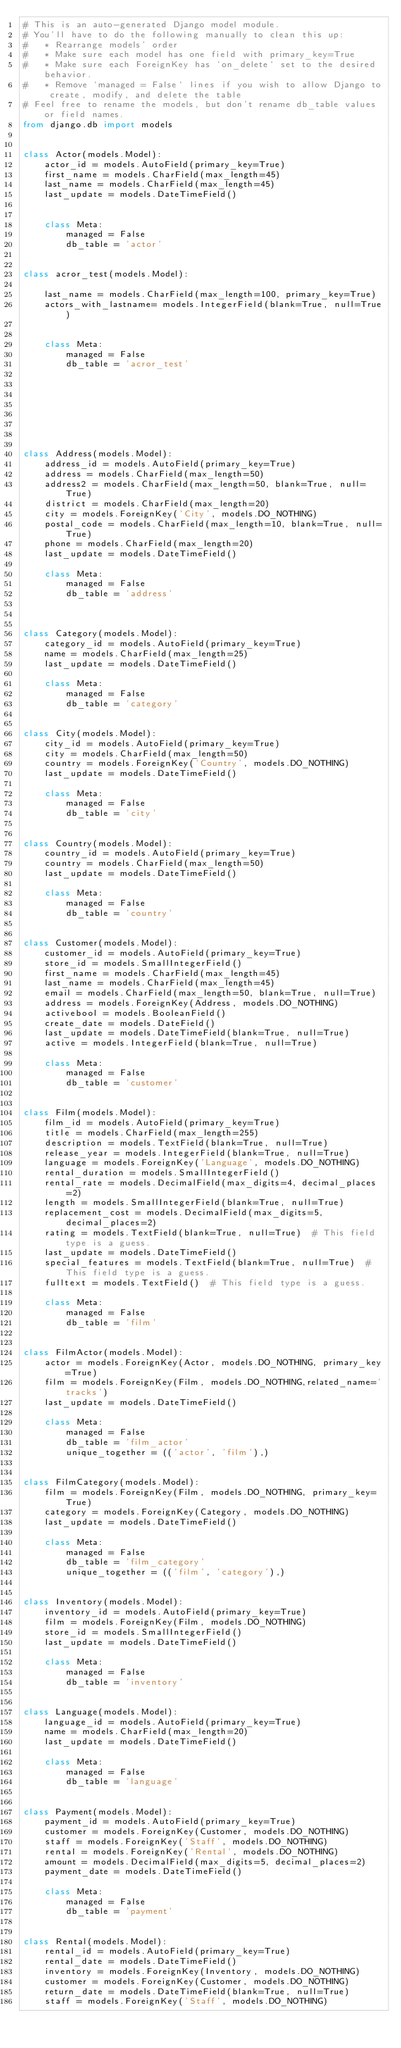<code> <loc_0><loc_0><loc_500><loc_500><_Python_># This is an auto-generated Django model module.
# You'll have to do the following manually to clean this up:
#   * Rearrange models' order
#   * Make sure each model has one field with primary_key=True
#   * Make sure each ForeignKey has `on_delete` set to the desired behavior.
#   * Remove `managed = False` lines if you wish to allow Django to create, modify, and delete the table
# Feel free to rename the models, but don't rename db_table values or field names.
from django.db import models


class Actor(models.Model):
    actor_id = models.AutoField(primary_key=True)
    first_name = models.CharField(max_length=45)
    last_name = models.CharField(max_length=45)
    last_update = models.DateTimeField()


    class Meta:
        managed = False
        db_table = 'actor'


class acror_test(models.Model):

    last_name = models.CharField(max_length=100, primary_key=True)
    actors_with_lastname= models.IntegerField(blank=True, null=True)


    class Meta:
        managed = False
        db_table = 'acror_test'








class Address(models.Model):
    address_id = models.AutoField(primary_key=True)
    address = models.CharField(max_length=50)
    address2 = models.CharField(max_length=50, blank=True, null=True)
    district = models.CharField(max_length=20)
    city = models.ForeignKey('City', models.DO_NOTHING)
    postal_code = models.CharField(max_length=10, blank=True, null=True)
    phone = models.CharField(max_length=20)
    last_update = models.DateTimeField()

    class Meta:
        managed = False
        db_table = 'address'



class Category(models.Model):
    category_id = models.AutoField(primary_key=True)
    name = models.CharField(max_length=25)
    last_update = models.DateTimeField()

    class Meta:
        managed = False
        db_table = 'category'


class City(models.Model):
    city_id = models.AutoField(primary_key=True)
    city = models.CharField(max_length=50)
    country = models.ForeignKey('Country', models.DO_NOTHING)
    last_update = models.DateTimeField()

    class Meta:
        managed = False
        db_table = 'city'


class Country(models.Model):
    country_id = models.AutoField(primary_key=True)
    country = models.CharField(max_length=50)
    last_update = models.DateTimeField()

    class Meta:
        managed = False
        db_table = 'country'


class Customer(models.Model):
    customer_id = models.AutoField(primary_key=True)
    store_id = models.SmallIntegerField()
    first_name = models.CharField(max_length=45)
    last_name = models.CharField(max_length=45)
    email = models.CharField(max_length=50, blank=True, null=True)
    address = models.ForeignKey(Address, models.DO_NOTHING)
    activebool = models.BooleanField()
    create_date = models.DateField()
    last_update = models.DateTimeField(blank=True, null=True)
    active = models.IntegerField(blank=True, null=True)

    class Meta:
        managed = False
        db_table = 'customer'


class Film(models.Model):
    film_id = models.AutoField(primary_key=True)
    title = models.CharField(max_length=255)
    description = models.TextField(blank=True, null=True)
    release_year = models.IntegerField(blank=True, null=True)
    language = models.ForeignKey('Language', models.DO_NOTHING)
    rental_duration = models.SmallIntegerField()
    rental_rate = models.DecimalField(max_digits=4, decimal_places=2)
    length = models.SmallIntegerField(blank=True, null=True)
    replacement_cost = models.DecimalField(max_digits=5, decimal_places=2)
    rating = models.TextField(blank=True, null=True)  # This field type is a guess.
    last_update = models.DateTimeField()
    special_features = models.TextField(blank=True, null=True)  # This field type is a guess.
    fulltext = models.TextField()  # This field type is a guess.

    class Meta:
        managed = False
        db_table = 'film'


class FilmActor(models.Model):
    actor = models.ForeignKey(Actor, models.DO_NOTHING, primary_key=True)
    film = models.ForeignKey(Film, models.DO_NOTHING,related_name='tracks')
    last_update = models.DateTimeField()

    class Meta:
        managed = False
        db_table = 'film_actor'
        unique_together = (('actor', 'film'),)


class FilmCategory(models.Model):
    film = models.ForeignKey(Film, models.DO_NOTHING, primary_key=True)
    category = models.ForeignKey(Category, models.DO_NOTHING)
    last_update = models.DateTimeField()

    class Meta:
        managed = False
        db_table = 'film_category'
        unique_together = (('film', 'category'),)


class Inventory(models.Model):
    inventory_id = models.AutoField(primary_key=True)
    film = models.ForeignKey(Film, models.DO_NOTHING)
    store_id = models.SmallIntegerField()
    last_update = models.DateTimeField()

    class Meta:
        managed = False
        db_table = 'inventory'


class Language(models.Model):
    language_id = models.AutoField(primary_key=True)
    name = models.CharField(max_length=20)
    last_update = models.DateTimeField()

    class Meta:
        managed = False
        db_table = 'language'


class Payment(models.Model):
    payment_id = models.AutoField(primary_key=True)
    customer = models.ForeignKey(Customer, models.DO_NOTHING)
    staff = models.ForeignKey('Staff', models.DO_NOTHING)
    rental = models.ForeignKey('Rental', models.DO_NOTHING)
    amount = models.DecimalField(max_digits=5, decimal_places=2)
    payment_date = models.DateTimeField()

    class Meta:
        managed = False
        db_table = 'payment'


class Rental(models.Model):
    rental_id = models.AutoField(primary_key=True)
    rental_date = models.DateTimeField()
    inventory = models.ForeignKey(Inventory, models.DO_NOTHING)
    customer = models.ForeignKey(Customer, models.DO_NOTHING)
    return_date = models.DateTimeField(blank=True, null=True)
    staff = models.ForeignKey('Staff', models.DO_NOTHING)</code> 